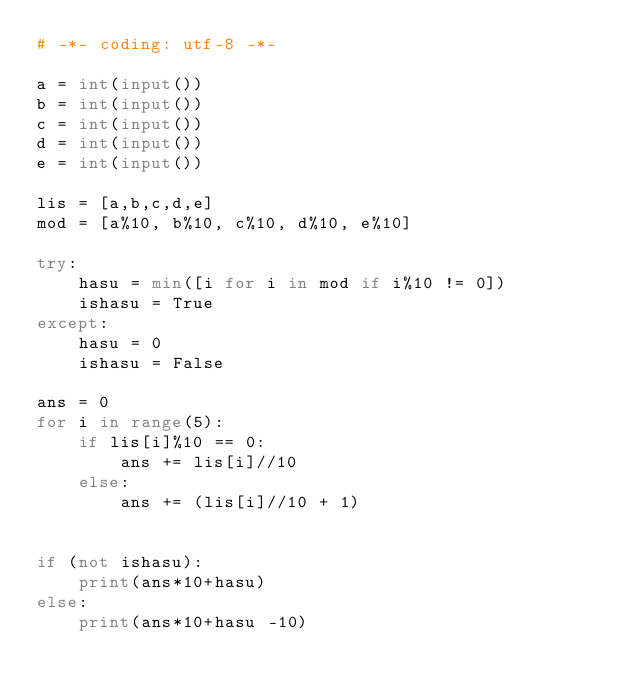<code> <loc_0><loc_0><loc_500><loc_500><_Python_># -*- coding: utf-8 -*-

a = int(input())
b = int(input())
c = int(input())
d = int(input())
e = int(input())

lis = [a,b,c,d,e]
mod = [a%10, b%10, c%10, d%10, e%10]

try:    
    hasu = min([i for i in mod if i%10 != 0])
    ishasu = True
except:
    hasu = 0
    ishasu = False

ans = 0
for i in range(5):
    if lis[i]%10 == 0:
        ans += lis[i]//10
    else:
        ans += (lis[i]//10 + 1)


if (not ishasu):
    print(ans*10+hasu)
else:
    print(ans*10+hasu -10)
</code> 